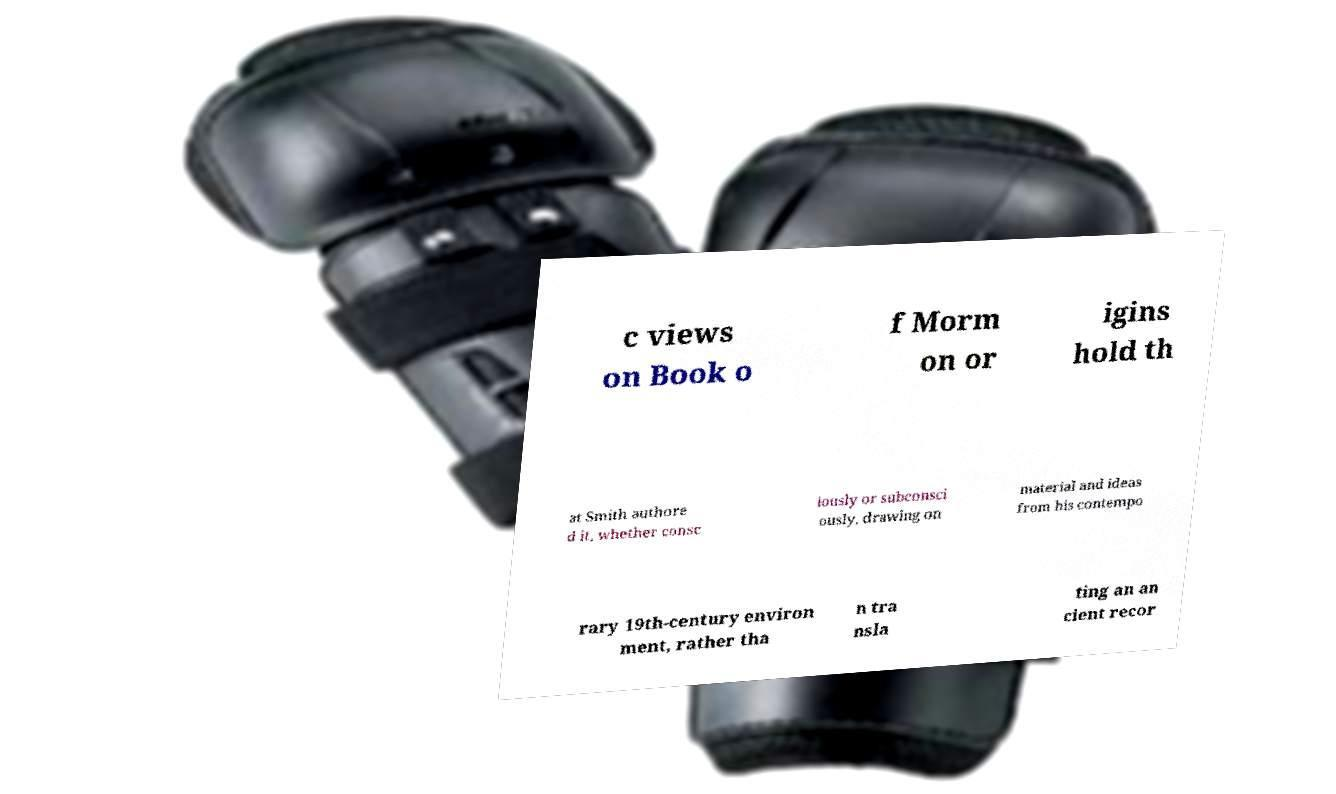Could you assist in decoding the text presented in this image and type it out clearly? c views on Book o f Morm on or igins hold th at Smith authore d it, whether consc iously or subconsci ously, drawing on material and ideas from his contempo rary 19th-century environ ment, rather tha n tra nsla ting an an cient recor 